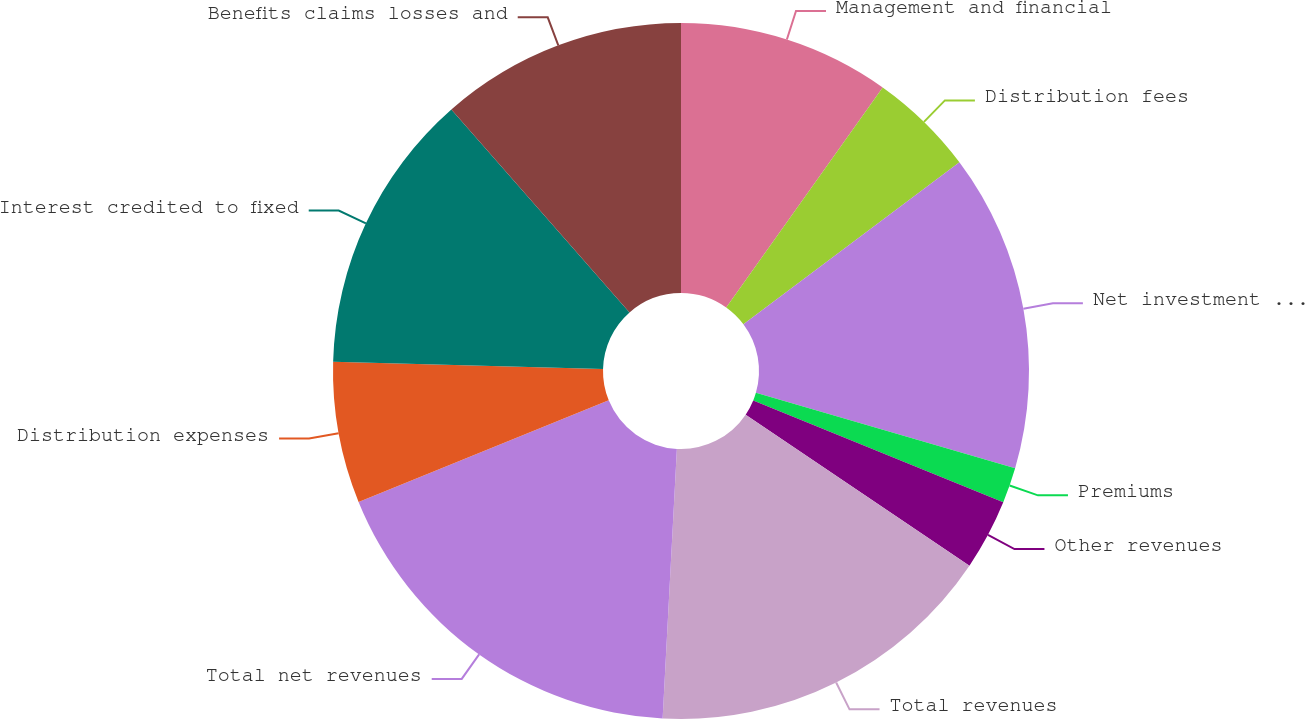<chart> <loc_0><loc_0><loc_500><loc_500><pie_chart><fcel>Management and financial<fcel>Distribution fees<fcel>Net investment income<fcel>Premiums<fcel>Other revenues<fcel>Total revenues<fcel>Total net revenues<fcel>Distribution expenses<fcel>Interest credited to fixed<fcel>Benefits claims losses and<nl><fcel>9.84%<fcel>4.92%<fcel>14.75%<fcel>1.65%<fcel>3.29%<fcel>16.39%<fcel>18.02%<fcel>6.56%<fcel>13.11%<fcel>11.47%<nl></chart> 